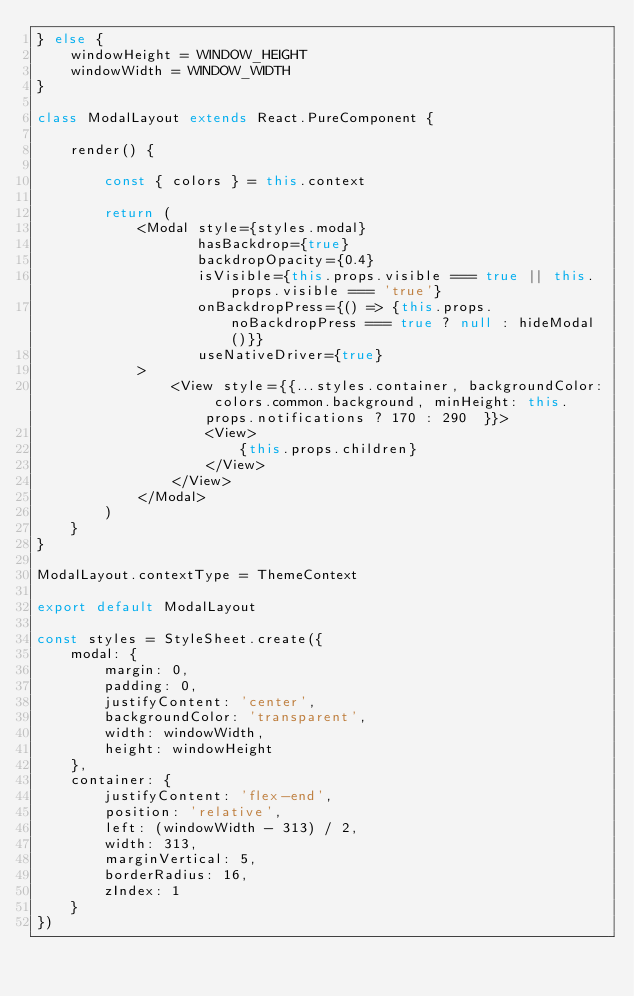Convert code to text. <code><loc_0><loc_0><loc_500><loc_500><_JavaScript_>} else {
    windowHeight = WINDOW_HEIGHT
    windowWidth = WINDOW_WIDTH
}

class ModalLayout extends React.PureComponent {

    render() {

        const { colors } = this.context

        return (
            <Modal style={styles.modal}
                   hasBackdrop={true}
                   backdropOpacity={0.4}
                   isVisible={this.props.visible === true || this.props.visible === 'true'}
                   onBackdropPress={() => {this.props.noBackdropPress === true ? null : hideModal()}}
                   useNativeDriver={true}
            >
                <View style={{...styles.container, backgroundColor: colors.common.background, minHeight: this.props.notifications ? 170 : 290  }}>
                    <View>
                        {this.props.children}
                    </View>
                </View>
            </Modal>
        )
    }
}

ModalLayout.contextType = ThemeContext

export default ModalLayout

const styles = StyleSheet.create({
    modal: {
        margin: 0,
        padding: 0,
        justifyContent: 'center',
        backgroundColor: 'transparent',
        width: windowWidth,
        height: windowHeight
    },
    container: {
        justifyContent: 'flex-end',
        position: 'relative',
        left: (windowWidth - 313) / 2,
        width: 313,
        marginVertical: 5,
        borderRadius: 16,
        zIndex: 1
    }
})
</code> 